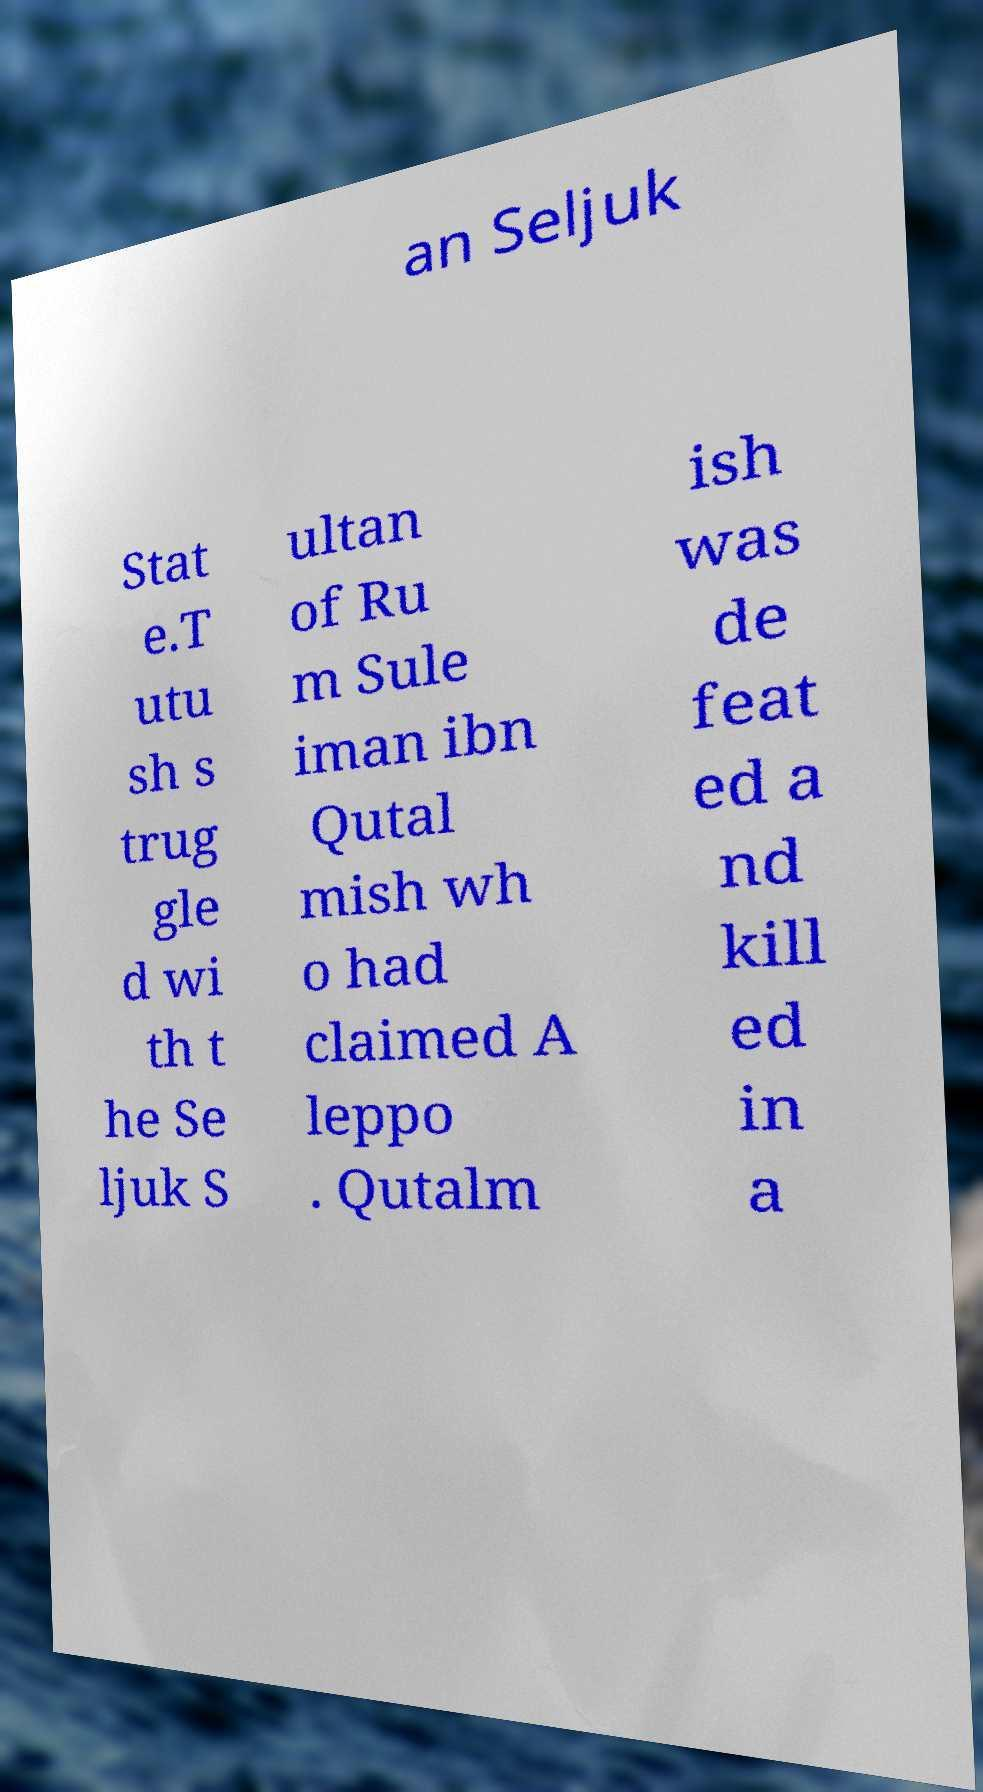There's text embedded in this image that I need extracted. Can you transcribe it verbatim? an Seljuk Stat e.T utu sh s trug gle d wi th t he Se ljuk S ultan of Ru m Sule iman ibn Qutal mish wh o had claimed A leppo . Qutalm ish was de feat ed a nd kill ed in a 